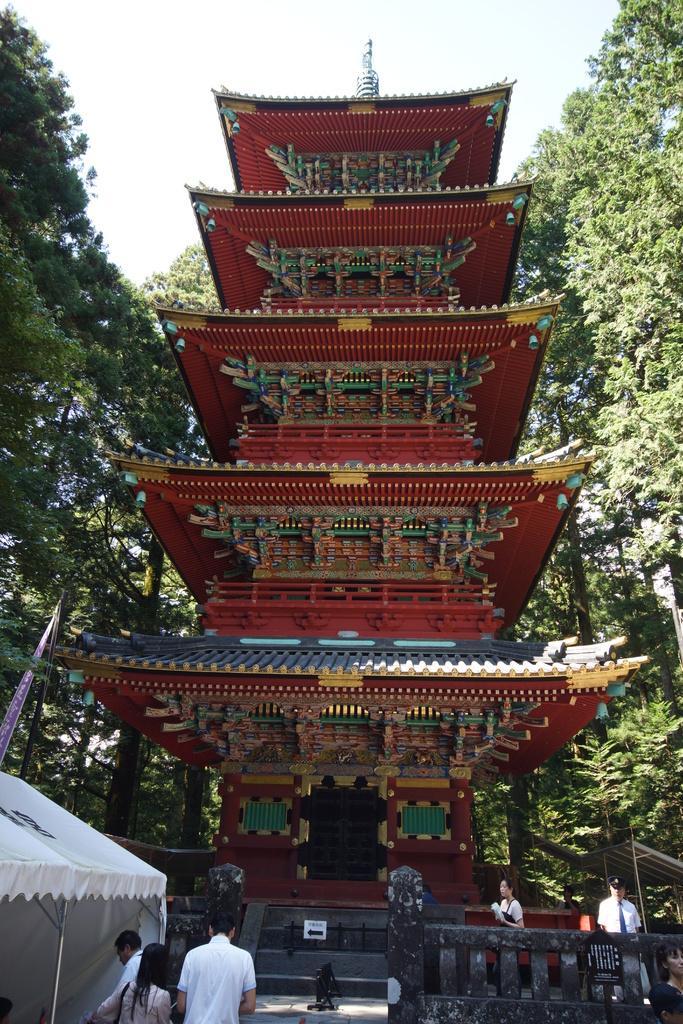Please provide a concise description of this image. In this picture we can see a temple here, in the background there are some trees, we can see some people standing here, at the left bottom there is a tent, we can see the sky at the top of the picture. 